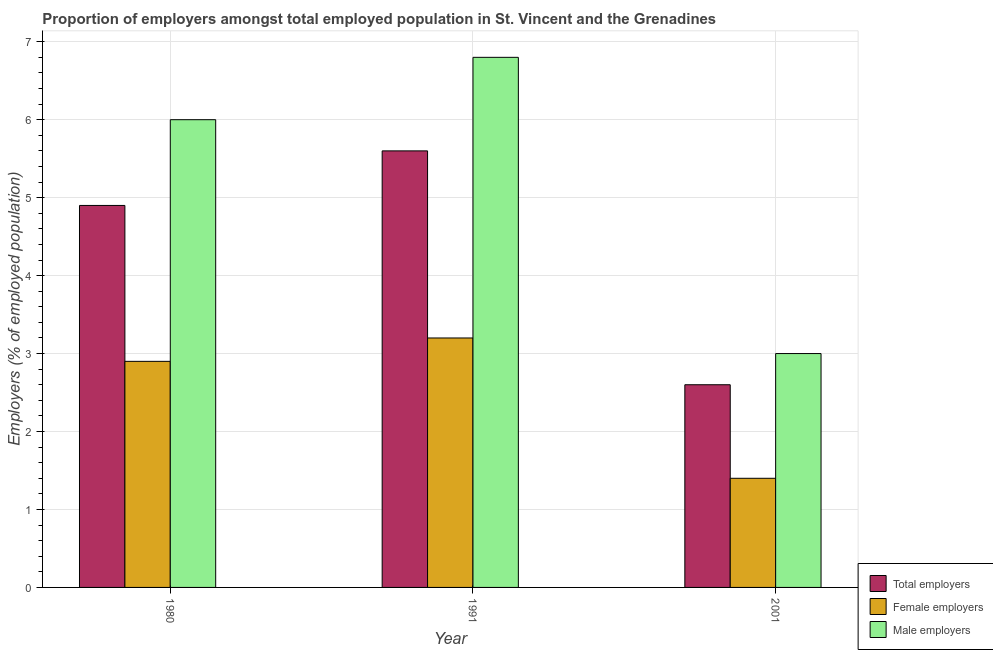How many different coloured bars are there?
Provide a succinct answer. 3. What is the label of the 1st group of bars from the left?
Ensure brevity in your answer.  1980. In how many cases, is the number of bars for a given year not equal to the number of legend labels?
Provide a succinct answer. 0. What is the percentage of total employers in 1991?
Provide a short and direct response. 5.6. Across all years, what is the maximum percentage of male employers?
Give a very brief answer. 6.8. Across all years, what is the minimum percentage of male employers?
Offer a terse response. 3. In which year was the percentage of male employers minimum?
Your response must be concise. 2001. What is the total percentage of female employers in the graph?
Your response must be concise. 7.5. What is the difference between the percentage of female employers in 1991 and that in 2001?
Ensure brevity in your answer.  1.8. What is the difference between the percentage of female employers in 1991 and the percentage of male employers in 2001?
Provide a succinct answer. 1.8. What is the average percentage of male employers per year?
Your response must be concise. 5.27. What is the ratio of the percentage of male employers in 1980 to that in 1991?
Offer a very short reply. 0.88. What is the difference between the highest and the second highest percentage of female employers?
Ensure brevity in your answer.  0.3. What is the difference between the highest and the lowest percentage of female employers?
Your answer should be very brief. 1.8. What does the 3rd bar from the left in 1980 represents?
Your answer should be compact. Male employers. What does the 3rd bar from the right in 2001 represents?
Your answer should be very brief. Total employers. How many bars are there?
Your answer should be very brief. 9. Are all the bars in the graph horizontal?
Offer a terse response. No. Does the graph contain any zero values?
Make the answer very short. No. Where does the legend appear in the graph?
Ensure brevity in your answer.  Bottom right. How many legend labels are there?
Your answer should be very brief. 3. How are the legend labels stacked?
Provide a short and direct response. Vertical. What is the title of the graph?
Provide a succinct answer. Proportion of employers amongst total employed population in St. Vincent and the Grenadines. What is the label or title of the X-axis?
Offer a terse response. Year. What is the label or title of the Y-axis?
Offer a very short reply. Employers (% of employed population). What is the Employers (% of employed population) of Total employers in 1980?
Ensure brevity in your answer.  4.9. What is the Employers (% of employed population) in Female employers in 1980?
Your response must be concise. 2.9. What is the Employers (% of employed population) of Total employers in 1991?
Make the answer very short. 5.6. What is the Employers (% of employed population) of Female employers in 1991?
Offer a terse response. 3.2. What is the Employers (% of employed population) in Male employers in 1991?
Give a very brief answer. 6.8. What is the Employers (% of employed population) of Total employers in 2001?
Your answer should be compact. 2.6. What is the Employers (% of employed population) of Female employers in 2001?
Provide a succinct answer. 1.4. What is the Employers (% of employed population) in Male employers in 2001?
Offer a terse response. 3. Across all years, what is the maximum Employers (% of employed population) of Total employers?
Your answer should be very brief. 5.6. Across all years, what is the maximum Employers (% of employed population) in Female employers?
Give a very brief answer. 3.2. Across all years, what is the maximum Employers (% of employed population) of Male employers?
Your answer should be compact. 6.8. Across all years, what is the minimum Employers (% of employed population) of Total employers?
Your response must be concise. 2.6. Across all years, what is the minimum Employers (% of employed population) in Female employers?
Offer a terse response. 1.4. Across all years, what is the minimum Employers (% of employed population) of Male employers?
Offer a very short reply. 3. What is the total Employers (% of employed population) in Female employers in the graph?
Give a very brief answer. 7.5. What is the total Employers (% of employed population) of Male employers in the graph?
Offer a terse response. 15.8. What is the difference between the Employers (% of employed population) in Total employers in 1980 and that in 1991?
Make the answer very short. -0.7. What is the difference between the Employers (% of employed population) in Female employers in 1980 and that in 1991?
Keep it short and to the point. -0.3. What is the difference between the Employers (% of employed population) in Male employers in 1980 and that in 1991?
Offer a terse response. -0.8. What is the difference between the Employers (% of employed population) of Total employers in 1980 and that in 2001?
Give a very brief answer. 2.3. What is the difference between the Employers (% of employed population) of Total employers in 1991 and that in 2001?
Give a very brief answer. 3. What is the difference between the Employers (% of employed population) of Female employers in 1980 and the Employers (% of employed population) of Male employers in 1991?
Make the answer very short. -3.9. What is the difference between the Employers (% of employed population) in Total employers in 1980 and the Employers (% of employed population) in Male employers in 2001?
Ensure brevity in your answer.  1.9. What is the difference between the Employers (% of employed population) of Female employers in 1980 and the Employers (% of employed population) of Male employers in 2001?
Offer a very short reply. -0.1. What is the difference between the Employers (% of employed population) in Total employers in 1991 and the Employers (% of employed population) in Female employers in 2001?
Your response must be concise. 4.2. What is the difference between the Employers (% of employed population) of Total employers in 1991 and the Employers (% of employed population) of Male employers in 2001?
Ensure brevity in your answer.  2.6. What is the difference between the Employers (% of employed population) in Female employers in 1991 and the Employers (% of employed population) in Male employers in 2001?
Give a very brief answer. 0.2. What is the average Employers (% of employed population) in Total employers per year?
Give a very brief answer. 4.37. What is the average Employers (% of employed population) in Male employers per year?
Your answer should be compact. 5.27. In the year 1980, what is the difference between the Employers (% of employed population) in Total employers and Employers (% of employed population) in Female employers?
Your answer should be very brief. 2. In the year 1980, what is the difference between the Employers (% of employed population) of Total employers and Employers (% of employed population) of Male employers?
Your response must be concise. -1.1. In the year 1991, what is the difference between the Employers (% of employed population) in Total employers and Employers (% of employed population) in Male employers?
Offer a terse response. -1.2. What is the ratio of the Employers (% of employed population) of Total employers in 1980 to that in 1991?
Your answer should be compact. 0.88. What is the ratio of the Employers (% of employed population) in Female employers in 1980 to that in 1991?
Provide a succinct answer. 0.91. What is the ratio of the Employers (% of employed population) of Male employers in 1980 to that in 1991?
Your answer should be compact. 0.88. What is the ratio of the Employers (% of employed population) of Total employers in 1980 to that in 2001?
Your answer should be compact. 1.88. What is the ratio of the Employers (% of employed population) of Female employers in 1980 to that in 2001?
Keep it short and to the point. 2.07. What is the ratio of the Employers (% of employed population) of Male employers in 1980 to that in 2001?
Ensure brevity in your answer.  2. What is the ratio of the Employers (% of employed population) in Total employers in 1991 to that in 2001?
Offer a very short reply. 2.15. What is the ratio of the Employers (% of employed population) in Female employers in 1991 to that in 2001?
Your answer should be compact. 2.29. What is the ratio of the Employers (% of employed population) in Male employers in 1991 to that in 2001?
Your answer should be very brief. 2.27. What is the difference between the highest and the second highest Employers (% of employed population) of Female employers?
Provide a succinct answer. 0.3. What is the difference between the highest and the lowest Employers (% of employed population) of Female employers?
Ensure brevity in your answer.  1.8. 